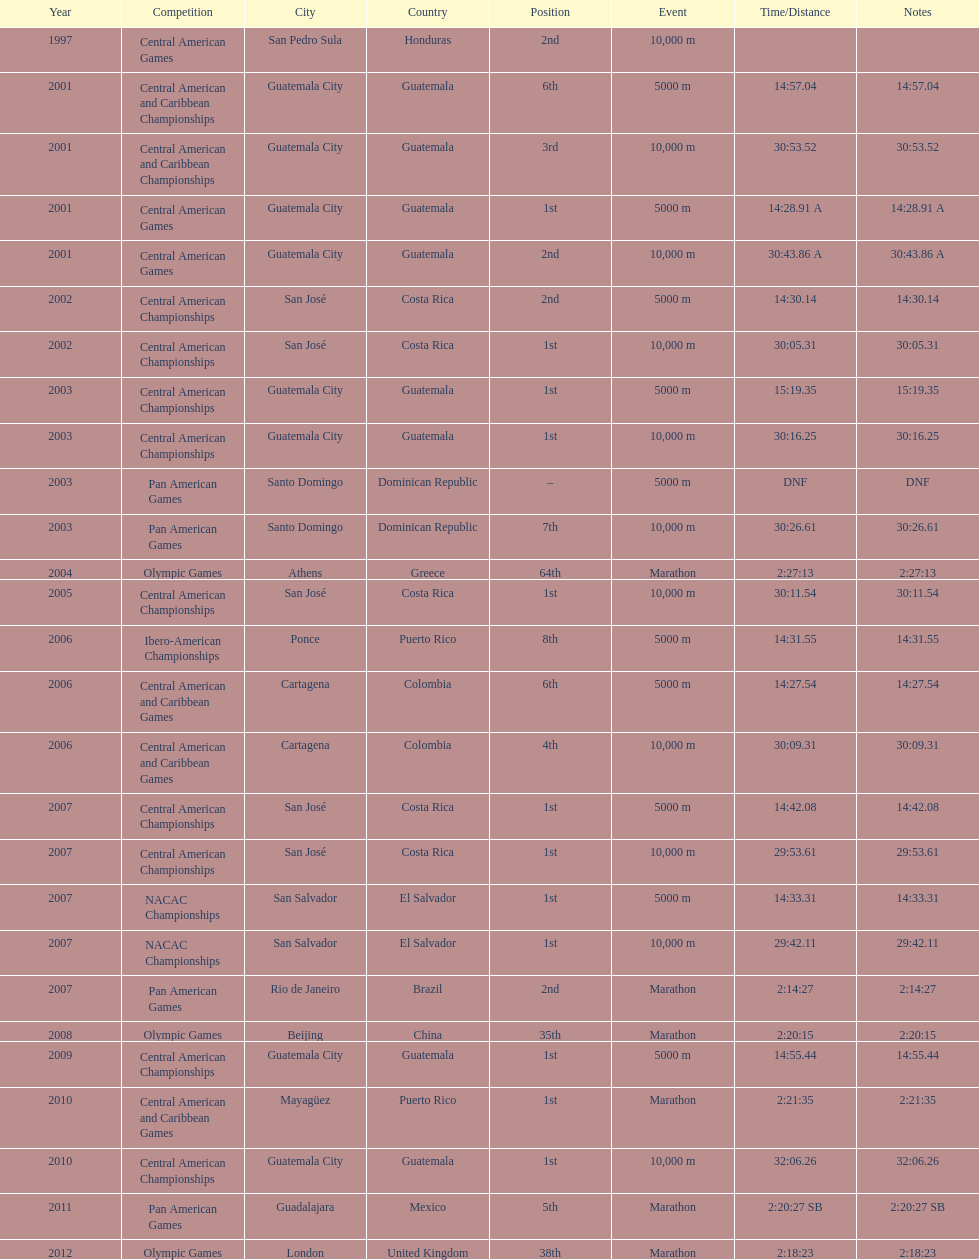What was the first competition this competitor competed in? Central American Games. 